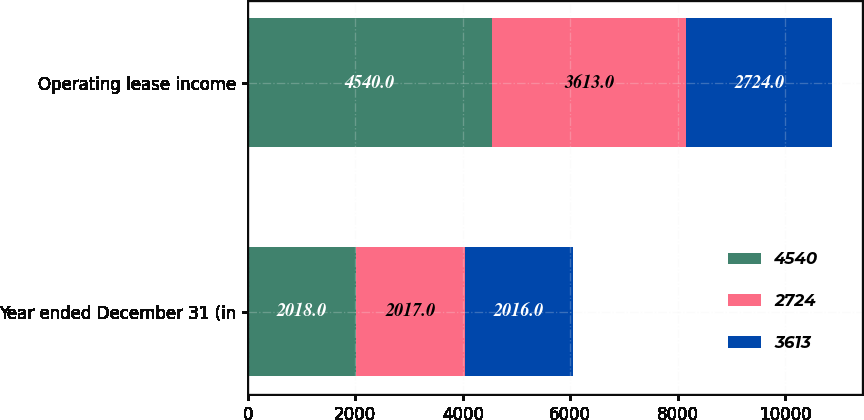Convert chart. <chart><loc_0><loc_0><loc_500><loc_500><stacked_bar_chart><ecel><fcel>Year ended December 31 (in<fcel>Operating lease income<nl><fcel>4540<fcel>2018<fcel>4540<nl><fcel>2724<fcel>2017<fcel>3613<nl><fcel>3613<fcel>2016<fcel>2724<nl></chart> 